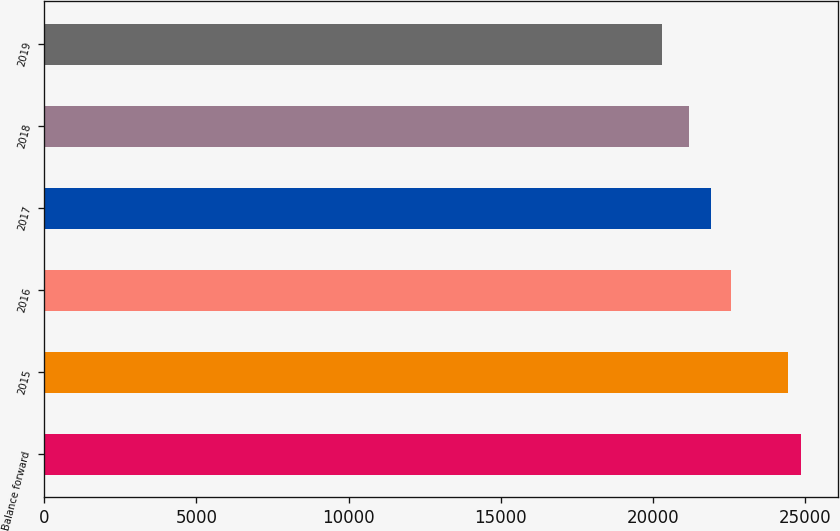Convert chart. <chart><loc_0><loc_0><loc_500><loc_500><bar_chart><fcel>Balance forward<fcel>2015<fcel>2016<fcel>2017<fcel>2018<fcel>2019<nl><fcel>24848.9<fcel>24429<fcel>22551<fcel>21921<fcel>21181<fcel>20290<nl></chart> 